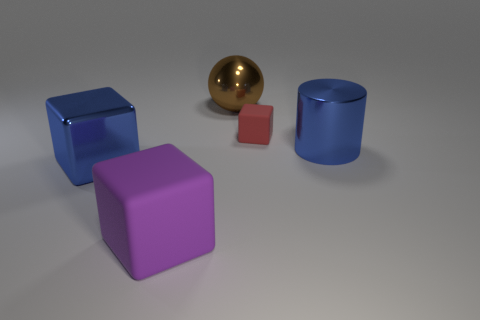Subtract all purple balls. Subtract all cyan blocks. How many balls are left? 1 Subtract all gray spheres. How many green blocks are left? 0 Add 4 purples. How many small things exist? 0 Subtract all blue metallic objects. Subtract all tiny red objects. How many objects are left? 2 Add 5 red matte things. How many red matte things are left? 6 Add 2 large purple things. How many large purple things exist? 3 Add 3 tiny matte objects. How many objects exist? 8 Subtract all red blocks. How many blocks are left? 2 Subtract all big matte cubes. How many cubes are left? 2 Subtract 1 blue blocks. How many objects are left? 4 